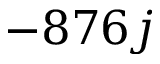<formula> <loc_0><loc_0><loc_500><loc_500>- 8 7 6 j</formula> 